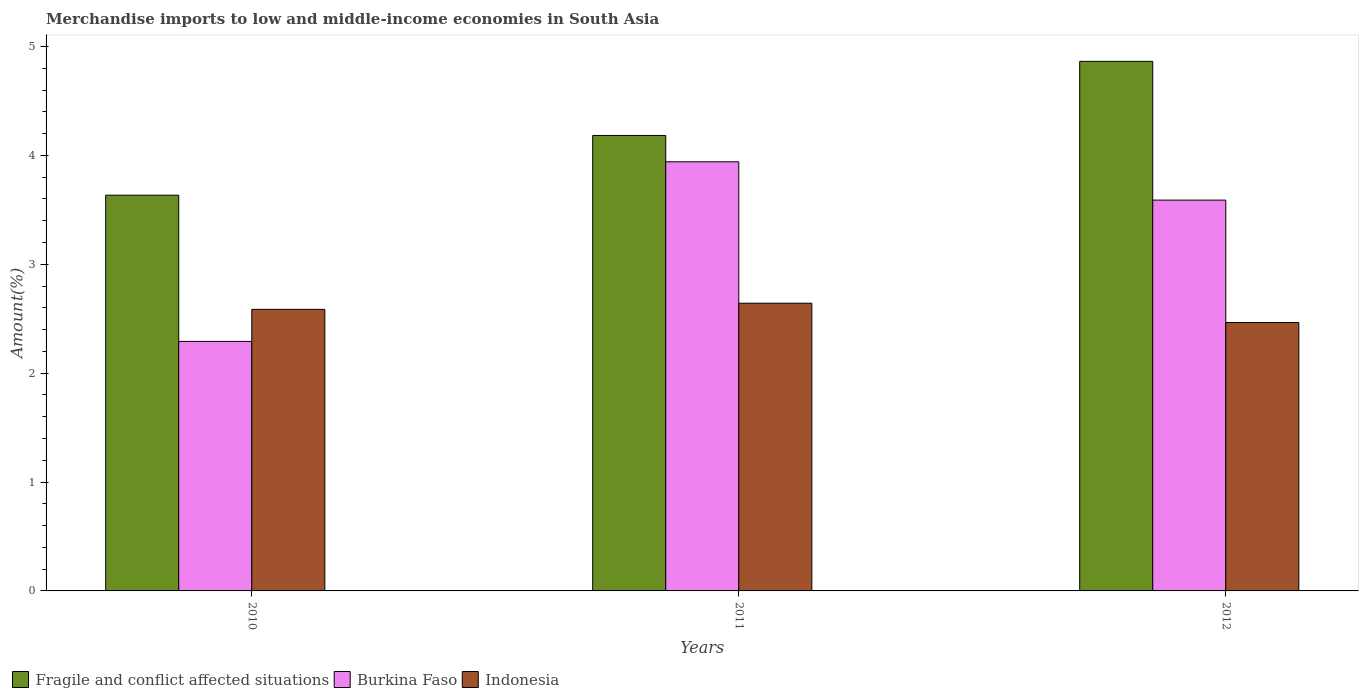How many different coloured bars are there?
Provide a short and direct response. 3. How many groups of bars are there?
Give a very brief answer. 3. Are the number of bars per tick equal to the number of legend labels?
Provide a succinct answer. Yes. Are the number of bars on each tick of the X-axis equal?
Your response must be concise. Yes. How many bars are there on the 3rd tick from the left?
Ensure brevity in your answer.  3. What is the percentage of amount earned from merchandise imports in Fragile and conflict affected situations in 2011?
Provide a short and direct response. 4.18. Across all years, what is the maximum percentage of amount earned from merchandise imports in Indonesia?
Your answer should be very brief. 2.64. Across all years, what is the minimum percentage of amount earned from merchandise imports in Indonesia?
Offer a terse response. 2.47. In which year was the percentage of amount earned from merchandise imports in Indonesia maximum?
Your answer should be compact. 2011. What is the total percentage of amount earned from merchandise imports in Burkina Faso in the graph?
Your answer should be compact. 9.82. What is the difference between the percentage of amount earned from merchandise imports in Indonesia in 2010 and that in 2011?
Your answer should be very brief. -0.06. What is the difference between the percentage of amount earned from merchandise imports in Fragile and conflict affected situations in 2011 and the percentage of amount earned from merchandise imports in Burkina Faso in 2010?
Your answer should be very brief. 1.89. What is the average percentage of amount earned from merchandise imports in Fragile and conflict affected situations per year?
Make the answer very short. 4.23. In the year 2010, what is the difference between the percentage of amount earned from merchandise imports in Indonesia and percentage of amount earned from merchandise imports in Fragile and conflict affected situations?
Make the answer very short. -1.05. In how many years, is the percentage of amount earned from merchandise imports in Fragile and conflict affected situations greater than 2.4 %?
Your response must be concise. 3. What is the ratio of the percentage of amount earned from merchandise imports in Indonesia in 2010 to that in 2011?
Your answer should be compact. 0.98. What is the difference between the highest and the second highest percentage of amount earned from merchandise imports in Burkina Faso?
Provide a succinct answer. 0.35. What is the difference between the highest and the lowest percentage of amount earned from merchandise imports in Indonesia?
Your response must be concise. 0.18. In how many years, is the percentage of amount earned from merchandise imports in Indonesia greater than the average percentage of amount earned from merchandise imports in Indonesia taken over all years?
Your answer should be compact. 2. What does the 2nd bar from the left in 2012 represents?
Ensure brevity in your answer.  Burkina Faso. What does the 2nd bar from the right in 2012 represents?
Keep it short and to the point. Burkina Faso. Is it the case that in every year, the sum of the percentage of amount earned from merchandise imports in Fragile and conflict affected situations and percentage of amount earned from merchandise imports in Burkina Faso is greater than the percentage of amount earned from merchandise imports in Indonesia?
Offer a very short reply. Yes. How many bars are there?
Provide a short and direct response. 9. Are all the bars in the graph horizontal?
Provide a short and direct response. No. How many years are there in the graph?
Your answer should be compact. 3. Are the values on the major ticks of Y-axis written in scientific E-notation?
Ensure brevity in your answer.  No. How many legend labels are there?
Your response must be concise. 3. What is the title of the graph?
Keep it short and to the point. Merchandise imports to low and middle-income economies in South Asia. What is the label or title of the Y-axis?
Offer a very short reply. Amount(%). What is the Amount(%) in Fragile and conflict affected situations in 2010?
Your answer should be compact. 3.63. What is the Amount(%) of Burkina Faso in 2010?
Give a very brief answer. 2.29. What is the Amount(%) in Indonesia in 2010?
Ensure brevity in your answer.  2.59. What is the Amount(%) of Fragile and conflict affected situations in 2011?
Your answer should be very brief. 4.18. What is the Amount(%) of Burkina Faso in 2011?
Ensure brevity in your answer.  3.94. What is the Amount(%) of Indonesia in 2011?
Make the answer very short. 2.64. What is the Amount(%) in Fragile and conflict affected situations in 2012?
Keep it short and to the point. 4.86. What is the Amount(%) of Burkina Faso in 2012?
Provide a short and direct response. 3.59. What is the Amount(%) in Indonesia in 2012?
Your answer should be very brief. 2.47. Across all years, what is the maximum Amount(%) of Fragile and conflict affected situations?
Keep it short and to the point. 4.86. Across all years, what is the maximum Amount(%) of Burkina Faso?
Your answer should be very brief. 3.94. Across all years, what is the maximum Amount(%) of Indonesia?
Your answer should be compact. 2.64. Across all years, what is the minimum Amount(%) in Fragile and conflict affected situations?
Offer a very short reply. 3.63. Across all years, what is the minimum Amount(%) in Burkina Faso?
Your answer should be very brief. 2.29. Across all years, what is the minimum Amount(%) of Indonesia?
Make the answer very short. 2.47. What is the total Amount(%) of Fragile and conflict affected situations in the graph?
Your response must be concise. 12.68. What is the total Amount(%) in Burkina Faso in the graph?
Your answer should be very brief. 9.82. What is the total Amount(%) in Indonesia in the graph?
Keep it short and to the point. 7.69. What is the difference between the Amount(%) in Fragile and conflict affected situations in 2010 and that in 2011?
Your answer should be compact. -0.55. What is the difference between the Amount(%) in Burkina Faso in 2010 and that in 2011?
Make the answer very short. -1.65. What is the difference between the Amount(%) of Indonesia in 2010 and that in 2011?
Offer a terse response. -0.06. What is the difference between the Amount(%) of Fragile and conflict affected situations in 2010 and that in 2012?
Your response must be concise. -1.23. What is the difference between the Amount(%) of Burkina Faso in 2010 and that in 2012?
Your answer should be compact. -1.3. What is the difference between the Amount(%) in Indonesia in 2010 and that in 2012?
Offer a very short reply. 0.12. What is the difference between the Amount(%) in Fragile and conflict affected situations in 2011 and that in 2012?
Ensure brevity in your answer.  -0.68. What is the difference between the Amount(%) of Burkina Faso in 2011 and that in 2012?
Offer a very short reply. 0.35. What is the difference between the Amount(%) of Indonesia in 2011 and that in 2012?
Provide a succinct answer. 0.18. What is the difference between the Amount(%) in Fragile and conflict affected situations in 2010 and the Amount(%) in Burkina Faso in 2011?
Keep it short and to the point. -0.31. What is the difference between the Amount(%) of Burkina Faso in 2010 and the Amount(%) of Indonesia in 2011?
Your answer should be very brief. -0.35. What is the difference between the Amount(%) of Fragile and conflict affected situations in 2010 and the Amount(%) of Burkina Faso in 2012?
Keep it short and to the point. 0.04. What is the difference between the Amount(%) of Fragile and conflict affected situations in 2010 and the Amount(%) of Indonesia in 2012?
Give a very brief answer. 1.17. What is the difference between the Amount(%) of Burkina Faso in 2010 and the Amount(%) of Indonesia in 2012?
Offer a very short reply. -0.17. What is the difference between the Amount(%) in Fragile and conflict affected situations in 2011 and the Amount(%) in Burkina Faso in 2012?
Give a very brief answer. 0.59. What is the difference between the Amount(%) of Fragile and conflict affected situations in 2011 and the Amount(%) of Indonesia in 2012?
Your answer should be compact. 1.72. What is the difference between the Amount(%) of Burkina Faso in 2011 and the Amount(%) of Indonesia in 2012?
Your answer should be compact. 1.48. What is the average Amount(%) in Fragile and conflict affected situations per year?
Make the answer very short. 4.23. What is the average Amount(%) in Burkina Faso per year?
Offer a very short reply. 3.27. What is the average Amount(%) of Indonesia per year?
Your response must be concise. 2.56. In the year 2010, what is the difference between the Amount(%) in Fragile and conflict affected situations and Amount(%) in Burkina Faso?
Your response must be concise. 1.34. In the year 2010, what is the difference between the Amount(%) in Fragile and conflict affected situations and Amount(%) in Indonesia?
Provide a succinct answer. 1.05. In the year 2010, what is the difference between the Amount(%) of Burkina Faso and Amount(%) of Indonesia?
Make the answer very short. -0.29. In the year 2011, what is the difference between the Amount(%) in Fragile and conflict affected situations and Amount(%) in Burkina Faso?
Offer a terse response. 0.24. In the year 2011, what is the difference between the Amount(%) in Fragile and conflict affected situations and Amount(%) in Indonesia?
Keep it short and to the point. 1.54. In the year 2011, what is the difference between the Amount(%) in Burkina Faso and Amount(%) in Indonesia?
Ensure brevity in your answer.  1.3. In the year 2012, what is the difference between the Amount(%) of Fragile and conflict affected situations and Amount(%) of Burkina Faso?
Make the answer very short. 1.27. In the year 2012, what is the difference between the Amount(%) of Fragile and conflict affected situations and Amount(%) of Indonesia?
Offer a very short reply. 2.4. In the year 2012, what is the difference between the Amount(%) of Burkina Faso and Amount(%) of Indonesia?
Ensure brevity in your answer.  1.12. What is the ratio of the Amount(%) in Fragile and conflict affected situations in 2010 to that in 2011?
Offer a very short reply. 0.87. What is the ratio of the Amount(%) of Burkina Faso in 2010 to that in 2011?
Keep it short and to the point. 0.58. What is the ratio of the Amount(%) of Indonesia in 2010 to that in 2011?
Make the answer very short. 0.98. What is the ratio of the Amount(%) of Fragile and conflict affected situations in 2010 to that in 2012?
Your response must be concise. 0.75. What is the ratio of the Amount(%) in Burkina Faso in 2010 to that in 2012?
Give a very brief answer. 0.64. What is the ratio of the Amount(%) of Indonesia in 2010 to that in 2012?
Offer a very short reply. 1.05. What is the ratio of the Amount(%) of Fragile and conflict affected situations in 2011 to that in 2012?
Make the answer very short. 0.86. What is the ratio of the Amount(%) of Burkina Faso in 2011 to that in 2012?
Offer a very short reply. 1.1. What is the ratio of the Amount(%) in Indonesia in 2011 to that in 2012?
Keep it short and to the point. 1.07. What is the difference between the highest and the second highest Amount(%) in Fragile and conflict affected situations?
Your answer should be compact. 0.68. What is the difference between the highest and the second highest Amount(%) of Burkina Faso?
Ensure brevity in your answer.  0.35. What is the difference between the highest and the second highest Amount(%) in Indonesia?
Keep it short and to the point. 0.06. What is the difference between the highest and the lowest Amount(%) in Fragile and conflict affected situations?
Ensure brevity in your answer.  1.23. What is the difference between the highest and the lowest Amount(%) in Burkina Faso?
Your answer should be compact. 1.65. What is the difference between the highest and the lowest Amount(%) of Indonesia?
Offer a terse response. 0.18. 